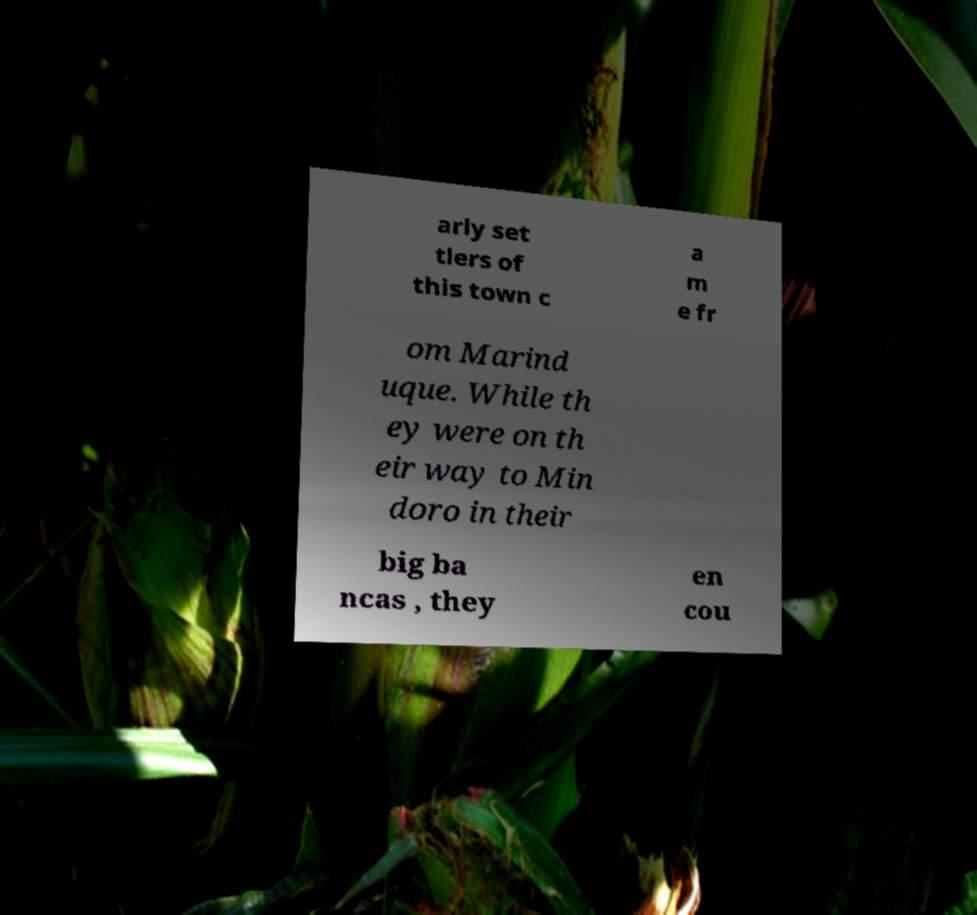For documentation purposes, I need the text within this image transcribed. Could you provide that? arly set tlers of this town c a m e fr om Marind uque. While th ey were on th eir way to Min doro in their big ba ncas , they en cou 